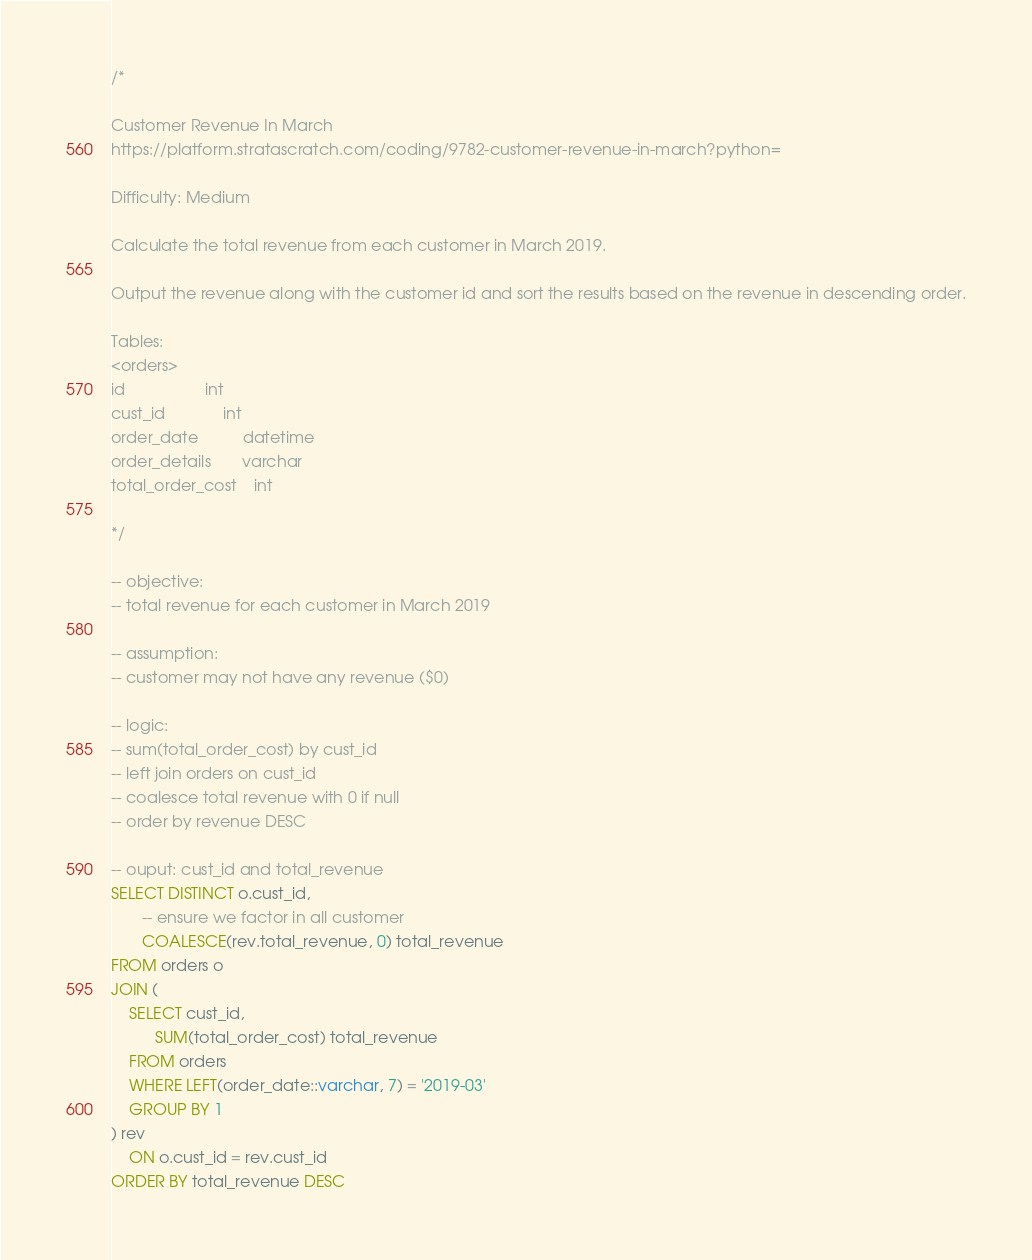<code> <loc_0><loc_0><loc_500><loc_500><_SQL_>/*

Customer Revenue In March
https://platform.stratascratch.com/coding/9782-customer-revenue-in-march?python=

Difficulty: Medium

Calculate the total revenue from each customer in March 2019.

Output the revenue along with the customer id and sort the results based on the revenue in descending order.

Tables:
<orders>
id                  int
cust_id             int
order_date          datetime
order_details       varchar
total_order_cost    int

*/

-- objective:
-- total revenue for each customer in March 2019

-- assumption:
-- customer may not have any revenue ($0)

-- logic:
-- sum(total_order_cost) by cust_id
-- left join orders on cust_id
-- coalesce total revenue with 0 if null
-- order by revenue DESC

-- ouput: cust_id and total_revenue
SELECT DISTINCT o.cust_id,
       -- ensure we factor in all customer
       COALESCE(rev.total_revenue, 0) total_revenue
FROM orders o
JOIN (
    SELECT cust_id,
          SUM(total_order_cost) total_revenue
    FROM orders
    WHERE LEFT(order_date::varchar, 7) = '2019-03'
    GROUP BY 1
) rev
    ON o.cust_id = rev.cust_id
ORDER BY total_revenue DESC
</code> 